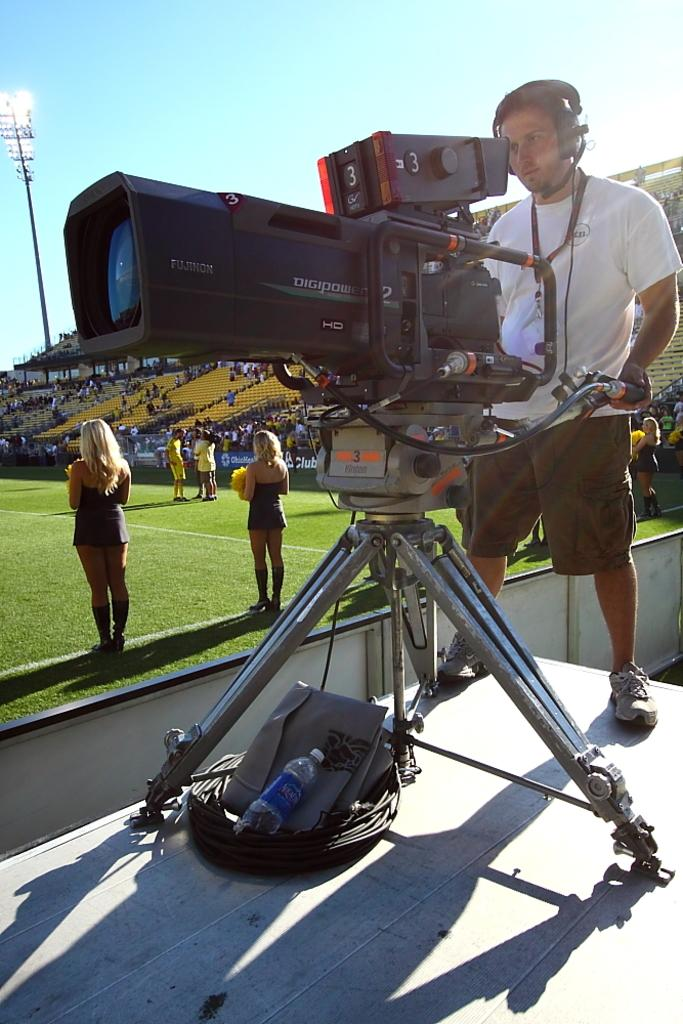<image>
Share a concise interpretation of the image provided. A cameraman looking through the viewfinder of an HD Digipower camera 